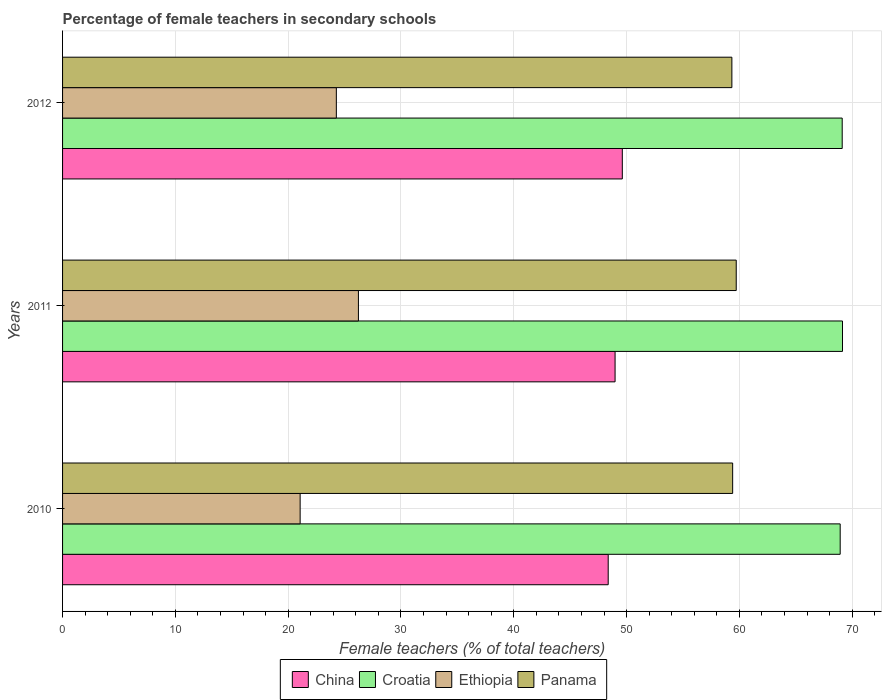How many different coloured bars are there?
Offer a terse response. 4. How many groups of bars are there?
Your answer should be very brief. 3. How many bars are there on the 1st tick from the top?
Ensure brevity in your answer.  4. In how many cases, is the number of bars for a given year not equal to the number of legend labels?
Make the answer very short. 0. What is the percentage of female teachers in China in 2010?
Offer a very short reply. 48.37. Across all years, what is the maximum percentage of female teachers in Ethiopia?
Your response must be concise. 26.23. Across all years, what is the minimum percentage of female teachers in Panama?
Make the answer very short. 59.33. In which year was the percentage of female teachers in China maximum?
Offer a terse response. 2012. What is the total percentage of female teachers in Croatia in the graph?
Offer a terse response. 207.18. What is the difference between the percentage of female teachers in China in 2010 and that in 2011?
Make the answer very short. -0.61. What is the difference between the percentage of female teachers in Ethiopia in 2011 and the percentage of female teachers in Croatia in 2012?
Offer a very short reply. -42.89. What is the average percentage of female teachers in Croatia per year?
Offer a terse response. 69.06. In the year 2012, what is the difference between the percentage of female teachers in Panama and percentage of female teachers in China?
Your answer should be very brief. 9.71. In how many years, is the percentage of female teachers in Croatia greater than 8 %?
Ensure brevity in your answer.  3. What is the ratio of the percentage of female teachers in Croatia in 2010 to that in 2012?
Offer a terse response. 1. Is the percentage of female teachers in Panama in 2010 less than that in 2012?
Provide a succinct answer. No. Is the difference between the percentage of female teachers in Panama in 2011 and 2012 greater than the difference between the percentage of female teachers in China in 2011 and 2012?
Your answer should be compact. Yes. What is the difference between the highest and the second highest percentage of female teachers in Croatia?
Make the answer very short. 0.03. What is the difference between the highest and the lowest percentage of female teachers in Croatia?
Your answer should be very brief. 0.2. In how many years, is the percentage of female teachers in Panama greater than the average percentage of female teachers in Panama taken over all years?
Make the answer very short. 1. Is the sum of the percentage of female teachers in China in 2010 and 2011 greater than the maximum percentage of female teachers in Ethiopia across all years?
Offer a terse response. Yes. Is it the case that in every year, the sum of the percentage of female teachers in Croatia and percentage of female teachers in Panama is greater than the sum of percentage of female teachers in Ethiopia and percentage of female teachers in China?
Make the answer very short. Yes. What does the 2nd bar from the top in 2011 represents?
Ensure brevity in your answer.  Ethiopia. What does the 4th bar from the bottom in 2011 represents?
Offer a terse response. Panama. How many bars are there?
Provide a succinct answer. 12. Are all the bars in the graph horizontal?
Your answer should be very brief. Yes. Are the values on the major ticks of X-axis written in scientific E-notation?
Provide a short and direct response. No. How are the legend labels stacked?
Your response must be concise. Horizontal. What is the title of the graph?
Provide a short and direct response. Percentage of female teachers in secondary schools. What is the label or title of the X-axis?
Provide a succinct answer. Female teachers (% of total teachers). What is the label or title of the Y-axis?
Keep it short and to the point. Years. What is the Female teachers (% of total teachers) in China in 2010?
Provide a succinct answer. 48.37. What is the Female teachers (% of total teachers) in Croatia in 2010?
Provide a short and direct response. 68.93. What is the Female teachers (% of total teachers) in Ethiopia in 2010?
Your answer should be very brief. 21.06. What is the Female teachers (% of total teachers) of Panama in 2010?
Make the answer very short. 59.4. What is the Female teachers (% of total teachers) in China in 2011?
Your response must be concise. 48.98. What is the Female teachers (% of total teachers) of Croatia in 2011?
Offer a terse response. 69.14. What is the Female teachers (% of total teachers) in Ethiopia in 2011?
Keep it short and to the point. 26.23. What is the Female teachers (% of total teachers) of Panama in 2011?
Offer a terse response. 59.72. What is the Female teachers (% of total teachers) of China in 2012?
Ensure brevity in your answer.  49.62. What is the Female teachers (% of total teachers) of Croatia in 2012?
Ensure brevity in your answer.  69.11. What is the Female teachers (% of total teachers) of Ethiopia in 2012?
Keep it short and to the point. 24.27. What is the Female teachers (% of total teachers) in Panama in 2012?
Give a very brief answer. 59.33. Across all years, what is the maximum Female teachers (% of total teachers) of China?
Your answer should be very brief. 49.62. Across all years, what is the maximum Female teachers (% of total teachers) of Croatia?
Make the answer very short. 69.14. Across all years, what is the maximum Female teachers (% of total teachers) in Ethiopia?
Give a very brief answer. 26.23. Across all years, what is the maximum Female teachers (% of total teachers) in Panama?
Your response must be concise. 59.72. Across all years, what is the minimum Female teachers (% of total teachers) in China?
Make the answer very short. 48.37. Across all years, what is the minimum Female teachers (% of total teachers) of Croatia?
Offer a very short reply. 68.93. Across all years, what is the minimum Female teachers (% of total teachers) in Ethiopia?
Provide a short and direct response. 21.06. Across all years, what is the minimum Female teachers (% of total teachers) of Panama?
Your answer should be very brief. 59.33. What is the total Female teachers (% of total teachers) of China in the graph?
Ensure brevity in your answer.  146.97. What is the total Female teachers (% of total teachers) of Croatia in the graph?
Provide a succinct answer. 207.18. What is the total Female teachers (% of total teachers) in Ethiopia in the graph?
Offer a terse response. 71.56. What is the total Female teachers (% of total teachers) in Panama in the graph?
Offer a very short reply. 178.45. What is the difference between the Female teachers (% of total teachers) in China in 2010 and that in 2011?
Make the answer very short. -0.61. What is the difference between the Female teachers (% of total teachers) in Croatia in 2010 and that in 2011?
Provide a short and direct response. -0.2. What is the difference between the Female teachers (% of total teachers) of Ethiopia in 2010 and that in 2011?
Your answer should be very brief. -5.17. What is the difference between the Female teachers (% of total teachers) of Panama in 2010 and that in 2011?
Offer a terse response. -0.32. What is the difference between the Female teachers (% of total teachers) of China in 2010 and that in 2012?
Your response must be concise. -1.25. What is the difference between the Female teachers (% of total teachers) of Croatia in 2010 and that in 2012?
Provide a short and direct response. -0.18. What is the difference between the Female teachers (% of total teachers) of Ethiopia in 2010 and that in 2012?
Provide a succinct answer. -3.21. What is the difference between the Female teachers (% of total teachers) in Panama in 2010 and that in 2012?
Provide a succinct answer. 0.07. What is the difference between the Female teachers (% of total teachers) of China in 2011 and that in 2012?
Provide a succinct answer. -0.64. What is the difference between the Female teachers (% of total teachers) of Croatia in 2011 and that in 2012?
Keep it short and to the point. 0.03. What is the difference between the Female teachers (% of total teachers) of Ethiopia in 2011 and that in 2012?
Your response must be concise. 1.96. What is the difference between the Female teachers (% of total teachers) of Panama in 2011 and that in 2012?
Provide a succinct answer. 0.39. What is the difference between the Female teachers (% of total teachers) in China in 2010 and the Female teachers (% of total teachers) in Croatia in 2011?
Provide a short and direct response. -20.77. What is the difference between the Female teachers (% of total teachers) of China in 2010 and the Female teachers (% of total teachers) of Ethiopia in 2011?
Make the answer very short. 22.14. What is the difference between the Female teachers (% of total teachers) in China in 2010 and the Female teachers (% of total teachers) in Panama in 2011?
Offer a very short reply. -11.35. What is the difference between the Female teachers (% of total teachers) of Croatia in 2010 and the Female teachers (% of total teachers) of Ethiopia in 2011?
Keep it short and to the point. 42.71. What is the difference between the Female teachers (% of total teachers) in Croatia in 2010 and the Female teachers (% of total teachers) in Panama in 2011?
Give a very brief answer. 9.22. What is the difference between the Female teachers (% of total teachers) of Ethiopia in 2010 and the Female teachers (% of total teachers) of Panama in 2011?
Make the answer very short. -38.66. What is the difference between the Female teachers (% of total teachers) in China in 2010 and the Female teachers (% of total teachers) in Croatia in 2012?
Your response must be concise. -20.74. What is the difference between the Female teachers (% of total teachers) in China in 2010 and the Female teachers (% of total teachers) in Ethiopia in 2012?
Offer a terse response. 24.1. What is the difference between the Female teachers (% of total teachers) of China in 2010 and the Female teachers (% of total teachers) of Panama in 2012?
Offer a terse response. -10.96. What is the difference between the Female teachers (% of total teachers) of Croatia in 2010 and the Female teachers (% of total teachers) of Ethiopia in 2012?
Your answer should be compact. 44.67. What is the difference between the Female teachers (% of total teachers) of Croatia in 2010 and the Female teachers (% of total teachers) of Panama in 2012?
Keep it short and to the point. 9.6. What is the difference between the Female teachers (% of total teachers) of Ethiopia in 2010 and the Female teachers (% of total teachers) of Panama in 2012?
Your answer should be compact. -38.27. What is the difference between the Female teachers (% of total teachers) in China in 2011 and the Female teachers (% of total teachers) in Croatia in 2012?
Provide a succinct answer. -20.13. What is the difference between the Female teachers (% of total teachers) of China in 2011 and the Female teachers (% of total teachers) of Ethiopia in 2012?
Give a very brief answer. 24.71. What is the difference between the Female teachers (% of total teachers) in China in 2011 and the Female teachers (% of total teachers) in Panama in 2012?
Provide a short and direct response. -10.35. What is the difference between the Female teachers (% of total teachers) in Croatia in 2011 and the Female teachers (% of total teachers) in Ethiopia in 2012?
Your response must be concise. 44.87. What is the difference between the Female teachers (% of total teachers) in Croatia in 2011 and the Female teachers (% of total teachers) in Panama in 2012?
Your answer should be compact. 9.81. What is the difference between the Female teachers (% of total teachers) of Ethiopia in 2011 and the Female teachers (% of total teachers) of Panama in 2012?
Keep it short and to the point. -33.11. What is the average Female teachers (% of total teachers) of China per year?
Ensure brevity in your answer.  48.99. What is the average Female teachers (% of total teachers) in Croatia per year?
Provide a succinct answer. 69.06. What is the average Female teachers (% of total teachers) of Ethiopia per year?
Your response must be concise. 23.85. What is the average Female teachers (% of total teachers) in Panama per year?
Provide a succinct answer. 59.48. In the year 2010, what is the difference between the Female teachers (% of total teachers) in China and Female teachers (% of total teachers) in Croatia?
Offer a very short reply. -20.57. In the year 2010, what is the difference between the Female teachers (% of total teachers) of China and Female teachers (% of total teachers) of Ethiopia?
Make the answer very short. 27.31. In the year 2010, what is the difference between the Female teachers (% of total teachers) in China and Female teachers (% of total teachers) in Panama?
Ensure brevity in your answer.  -11.03. In the year 2010, what is the difference between the Female teachers (% of total teachers) in Croatia and Female teachers (% of total teachers) in Ethiopia?
Offer a very short reply. 47.87. In the year 2010, what is the difference between the Female teachers (% of total teachers) of Croatia and Female teachers (% of total teachers) of Panama?
Offer a terse response. 9.53. In the year 2010, what is the difference between the Female teachers (% of total teachers) in Ethiopia and Female teachers (% of total teachers) in Panama?
Your response must be concise. -38.34. In the year 2011, what is the difference between the Female teachers (% of total teachers) in China and Female teachers (% of total teachers) in Croatia?
Provide a succinct answer. -20.16. In the year 2011, what is the difference between the Female teachers (% of total teachers) in China and Female teachers (% of total teachers) in Ethiopia?
Give a very brief answer. 22.75. In the year 2011, what is the difference between the Female teachers (% of total teachers) in China and Female teachers (% of total teachers) in Panama?
Provide a succinct answer. -10.74. In the year 2011, what is the difference between the Female teachers (% of total teachers) in Croatia and Female teachers (% of total teachers) in Ethiopia?
Your answer should be very brief. 42.91. In the year 2011, what is the difference between the Female teachers (% of total teachers) in Croatia and Female teachers (% of total teachers) in Panama?
Make the answer very short. 9.42. In the year 2011, what is the difference between the Female teachers (% of total teachers) of Ethiopia and Female teachers (% of total teachers) of Panama?
Your answer should be compact. -33.49. In the year 2012, what is the difference between the Female teachers (% of total teachers) in China and Female teachers (% of total teachers) in Croatia?
Your answer should be very brief. -19.49. In the year 2012, what is the difference between the Female teachers (% of total teachers) in China and Female teachers (% of total teachers) in Ethiopia?
Make the answer very short. 25.35. In the year 2012, what is the difference between the Female teachers (% of total teachers) in China and Female teachers (% of total teachers) in Panama?
Ensure brevity in your answer.  -9.71. In the year 2012, what is the difference between the Female teachers (% of total teachers) of Croatia and Female teachers (% of total teachers) of Ethiopia?
Offer a terse response. 44.84. In the year 2012, what is the difference between the Female teachers (% of total teachers) of Croatia and Female teachers (% of total teachers) of Panama?
Provide a short and direct response. 9.78. In the year 2012, what is the difference between the Female teachers (% of total teachers) in Ethiopia and Female teachers (% of total teachers) in Panama?
Offer a very short reply. -35.06. What is the ratio of the Female teachers (% of total teachers) in China in 2010 to that in 2011?
Your answer should be very brief. 0.99. What is the ratio of the Female teachers (% of total teachers) of Ethiopia in 2010 to that in 2011?
Provide a succinct answer. 0.8. What is the ratio of the Female teachers (% of total teachers) of Panama in 2010 to that in 2011?
Make the answer very short. 0.99. What is the ratio of the Female teachers (% of total teachers) of China in 2010 to that in 2012?
Provide a succinct answer. 0.97. What is the ratio of the Female teachers (% of total teachers) of Croatia in 2010 to that in 2012?
Give a very brief answer. 1. What is the ratio of the Female teachers (% of total teachers) of Ethiopia in 2010 to that in 2012?
Make the answer very short. 0.87. What is the ratio of the Female teachers (% of total teachers) of China in 2011 to that in 2012?
Your response must be concise. 0.99. What is the ratio of the Female teachers (% of total teachers) of Ethiopia in 2011 to that in 2012?
Keep it short and to the point. 1.08. What is the ratio of the Female teachers (% of total teachers) in Panama in 2011 to that in 2012?
Make the answer very short. 1.01. What is the difference between the highest and the second highest Female teachers (% of total teachers) in China?
Your response must be concise. 0.64. What is the difference between the highest and the second highest Female teachers (% of total teachers) of Croatia?
Keep it short and to the point. 0.03. What is the difference between the highest and the second highest Female teachers (% of total teachers) in Ethiopia?
Give a very brief answer. 1.96. What is the difference between the highest and the second highest Female teachers (% of total teachers) of Panama?
Make the answer very short. 0.32. What is the difference between the highest and the lowest Female teachers (% of total teachers) in China?
Offer a very short reply. 1.25. What is the difference between the highest and the lowest Female teachers (% of total teachers) of Croatia?
Your answer should be compact. 0.2. What is the difference between the highest and the lowest Female teachers (% of total teachers) of Ethiopia?
Give a very brief answer. 5.17. What is the difference between the highest and the lowest Female teachers (% of total teachers) in Panama?
Provide a short and direct response. 0.39. 